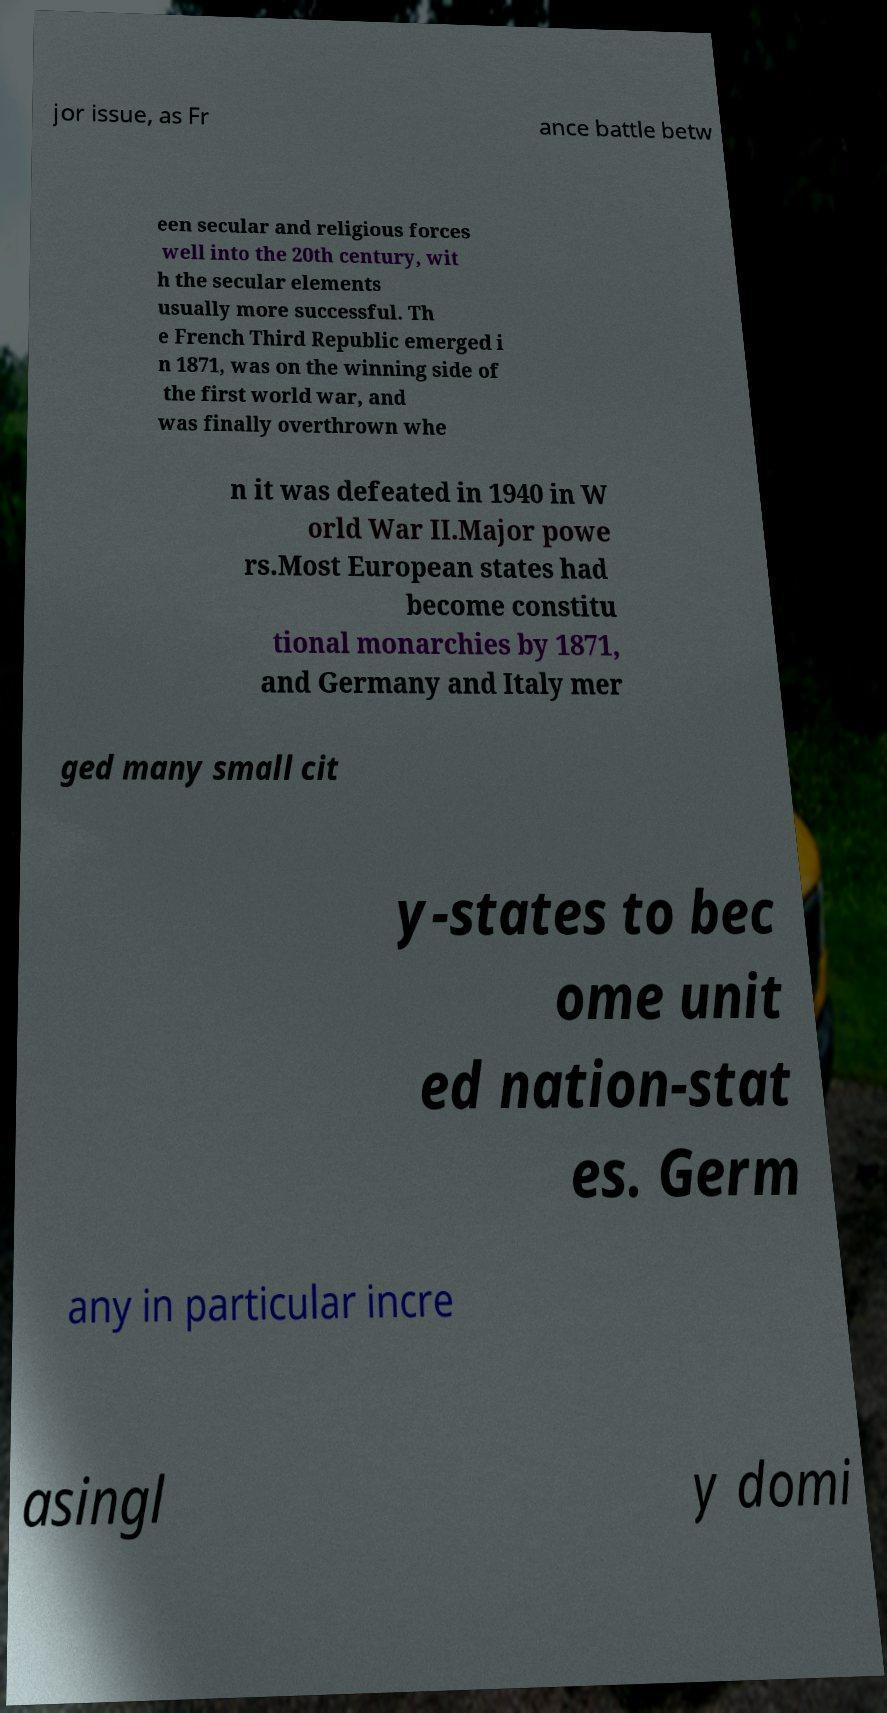Please identify and transcribe the text found in this image. jor issue, as Fr ance battle betw een secular and religious forces well into the 20th century, wit h the secular elements usually more successful. Th e French Third Republic emerged i n 1871, was on the winning side of the first world war, and was finally overthrown whe n it was defeated in 1940 in W orld War II.Major powe rs.Most European states had become constitu tional monarchies by 1871, and Germany and Italy mer ged many small cit y-states to bec ome unit ed nation-stat es. Germ any in particular incre asingl y domi 